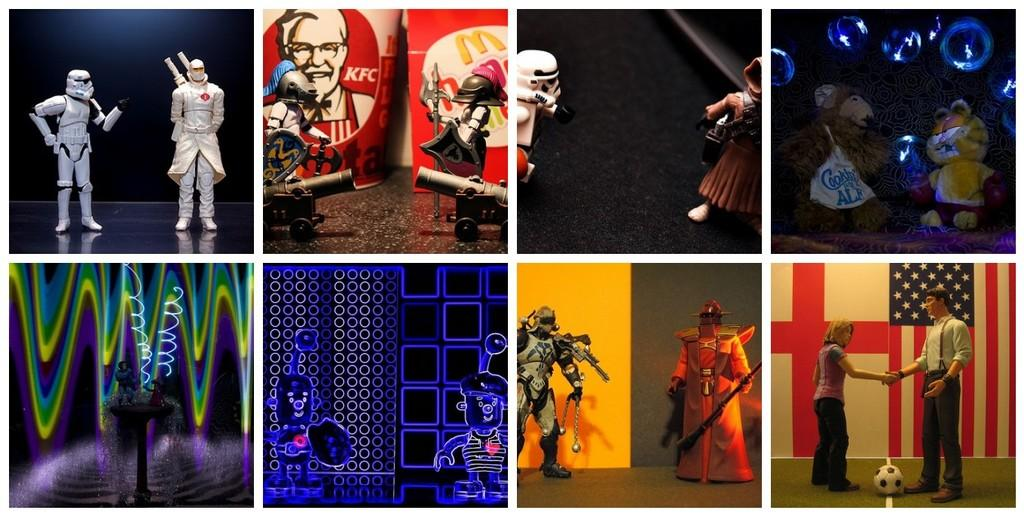What type of photos are present in the image? The image contains collage photos. What are some of the objects featured in the collage photos? The collage photos include toys of different sizes. Can you identify any specific toy in the collage photos? Yes, a ball is visible in the collage photos. What is the surface visible in the image? There is a floor visible in the image. What type of ocean can be seen in the background of the image? There is no ocean present in the image; it features collage photos with toys and a ball on a floor. 